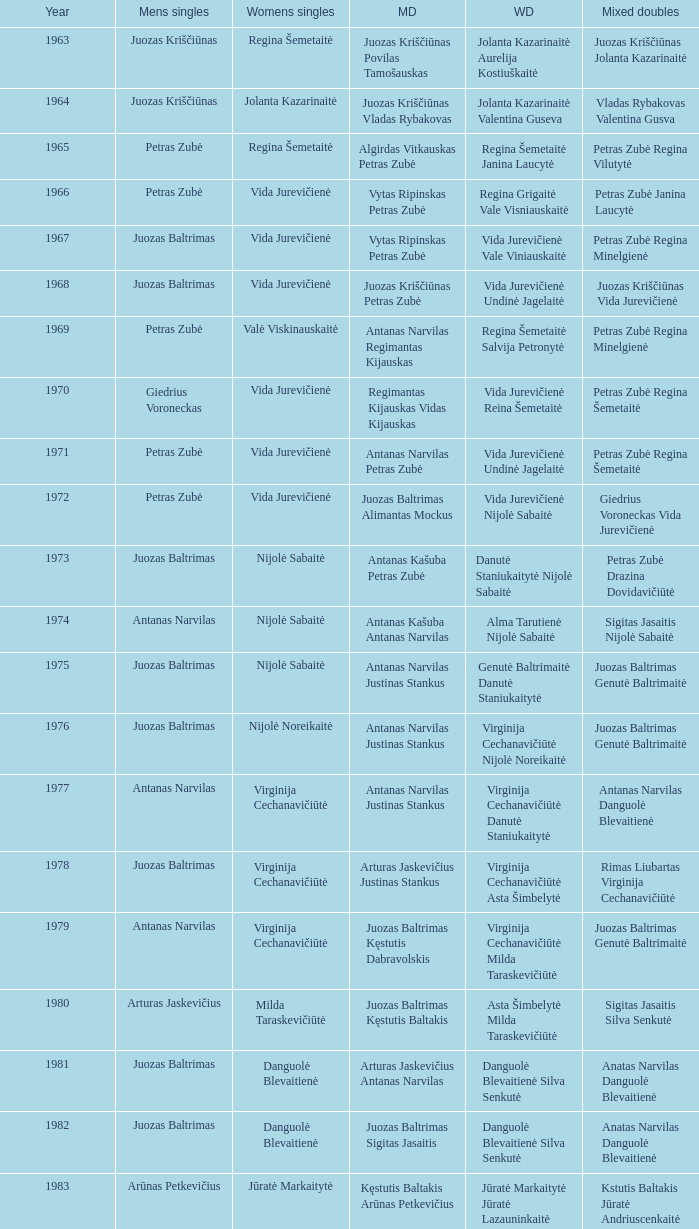What was the first year of the Lithuanian National Badminton Championships? 1963.0. 